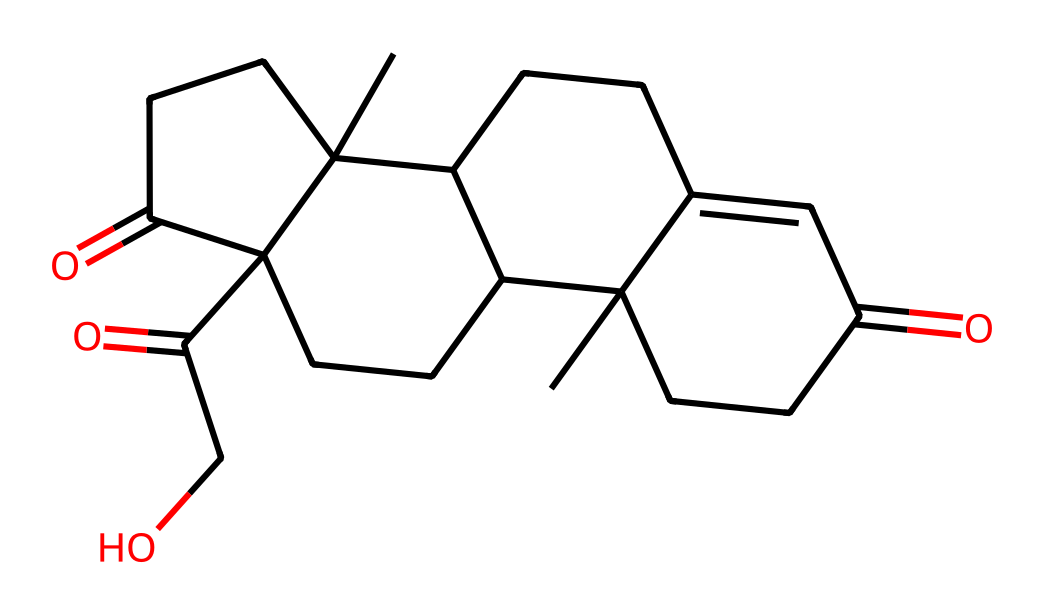What is the molecular formula of this hormone? To determine the molecular formula, we need to count the number of each type of atom in the provided SMILES representation. The structure contains carbons (C), hydrogens (H), and oxygens (O). By analyzing the SMILES, we find there are 21 carbon atoms, 30 hydrogen atoms, and 5 oxygen atoms, which gives us the molecular formula C21H30O5.
Answer: C21H30O5 How many rings are present in the structure? The structure includes distinct circular patterns indicative of rings. By closely examining the SMILES and recognizing the fused ring structures, we identify a total of 4 rings present in the molecule.
Answer: 4 What type of chemical is cortisol classified as? Cortisol is classified as a steroid, which can be determined by the complex ring structures present and the functional groups such as ketones and hydroxyl groups attached to the carbon framework.
Answer: steroid What functional groups can be identified in this molecule? By examining the chemical structure represented by the SMILES notation, we can identify ketones (due to the presence of carbonyl groups) and hydroxyl groups (indicated by the presence of -OH groups), making these the notable functional groups in cortisol.
Answer: ketones and hydroxyl groups What is the significance of cortisol in stress management? Cortisol plays a crucial role as a stress hormone, regulating various physiological responses to stress by modulating metabolism and immune function, which helps the body respond to stress more effectively.
Answer: stress hormone How many oxygen atoms are in cortisol's structure? To identify the number of oxygen atoms within the cortisol structure, we can analyze the SMILES representation carefully and count each occurrence of the oxygen (O) symbol. The count reveals there are 5 oxygen atoms in this molecule.
Answer: 5 